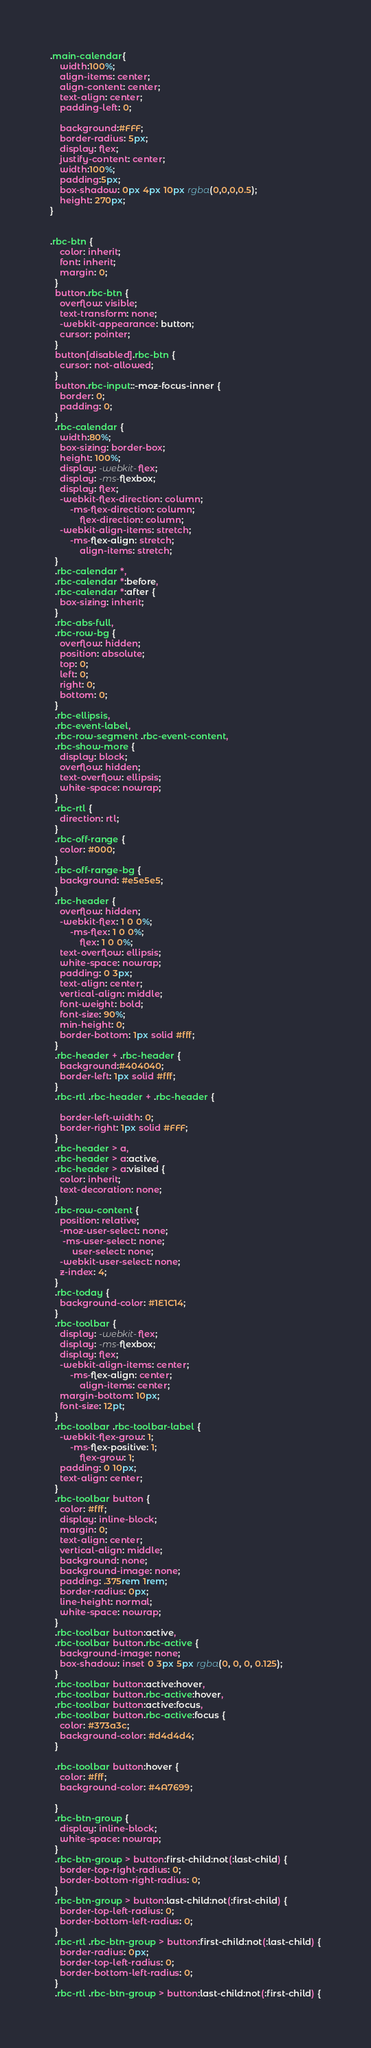Convert code to text. <code><loc_0><loc_0><loc_500><loc_500><_CSS_>.main-calendar{
    width:100%;
    align-items: center;
    align-content: center;
    text-align: center;
    padding-left: 0;
    
    background:#FFF;
    border-radius: 5px;
    display: flex;
    justify-content: center;
    width:100%;
    padding:5px;
    box-shadow: 0px 4px 10px rgba(0,0,0,0.5);
    height: 270px;
}


.rbc-btn {
    color: inherit;
    font: inherit;
    margin: 0;
  }
  button.rbc-btn {
    overflow: visible;
    text-transform: none;
    -webkit-appearance: button;
    cursor: pointer;
  }
  button[disabled].rbc-btn {
    cursor: not-allowed;
  }
  button.rbc-input::-moz-focus-inner {
    border: 0;
    padding: 0;
  }
  .rbc-calendar {
    width:80%;
    box-sizing: border-box;
    height: 100%;
    display: -webkit-flex;
    display: -ms-flexbox;
    display: flex;
    -webkit-flex-direction: column;
        -ms-flex-direction: column;
            flex-direction: column;
    -webkit-align-items: stretch;
        -ms-flex-align: stretch;
            align-items: stretch;
  }
  .rbc-calendar *,
  .rbc-calendar *:before,
  .rbc-calendar *:after {
    box-sizing: inherit;
  }
  .rbc-abs-full,
  .rbc-row-bg {
    overflow: hidden;
    position: absolute;
    top: 0;
    left: 0;
    right: 0;
    bottom: 0;
  }
  .rbc-ellipsis,
  .rbc-event-label,
  .rbc-row-segment .rbc-event-content,
  .rbc-show-more {
    display: block;
    overflow: hidden;
    text-overflow: ellipsis;
    white-space: nowrap;
  }
  .rbc-rtl {
    direction: rtl;
  }
  .rbc-off-range {
    color: #000;
  }
  .rbc-off-range-bg {
    background: #e5e5e5;
  }
  .rbc-header {
    overflow: hidden;
    -webkit-flex: 1 0 0%;
        -ms-flex: 1 0 0%;
            flex: 1 0 0%;
    text-overflow: ellipsis;
    white-space: nowrap;
    padding: 0 3px;
    text-align: center;
    vertical-align: middle;
    font-weight: bold;
    font-size: 90%;
    min-height: 0;
    border-bottom: 1px solid #fff;
  }
  .rbc-header + .rbc-header {
    background:#404040;
    border-left: 1px solid #fff;
  }
  .rbc-rtl .rbc-header + .rbc-header {
      
    border-left-width: 0;
    border-right: 1px solid #FFF;
  }
  .rbc-header > a,
  .rbc-header > a:active,
  .rbc-header > a:visited {
    color: inherit;
    text-decoration: none;
  }
  .rbc-row-content {
    position: relative;
    -moz-user-select: none;
     -ms-user-select: none;
         user-select: none;
    -webkit-user-select: none;
    z-index: 4;
  }
  .rbc-today {
    background-color: #1E1C14;
  }
  .rbc-toolbar {
    display: -webkit-flex;
    display: -ms-flexbox;
    display: flex;
    -webkit-align-items: center;
        -ms-flex-align: center;
            align-items: center;
    margin-bottom: 10px;
    font-size: 12pt;
  }
  .rbc-toolbar .rbc-toolbar-label {
    -webkit-flex-grow: 1;
        -ms-flex-positive: 1;
            flex-grow: 1;
    padding: 0 10px;
    text-align: center;
  }
  .rbc-toolbar button {
    color: #fff;
    display: inline-block;
    margin: 0;
    text-align: center;
    vertical-align: middle;
    background: none;
    background-image: none;
    padding: .375rem 1rem;
    border-radius: 0px;
    line-height: normal;
    white-space: nowrap;
  }
  .rbc-toolbar button:active,
  .rbc-toolbar button.rbc-active {
    background-image: none;
    box-shadow: inset 0 3px 5px rgba(0, 0, 0, 0.125);
  }
  .rbc-toolbar button:active:hover,
  .rbc-toolbar button.rbc-active:hover,
  .rbc-toolbar button:active:focus,
  .rbc-toolbar button.rbc-active:focus {
    color: #373a3c;
    background-color: #d4d4d4;
  }

  .rbc-toolbar button:hover {
    color: #fff;
    background-color: #4A7699;
   
  }
  .rbc-btn-group {
    display: inline-block;
    white-space: nowrap;
  }
  .rbc-btn-group > button:first-child:not(:last-child) {
    border-top-right-radius: 0;
    border-bottom-right-radius: 0;
  }
  .rbc-btn-group > button:last-child:not(:first-child) {
    border-top-left-radius: 0;
    border-bottom-left-radius: 0;
  }
  .rbc-rtl .rbc-btn-group > button:first-child:not(:last-child) {
    border-radius: 0px;
    border-top-left-radius: 0;
    border-bottom-left-radius: 0;
  }
  .rbc-rtl .rbc-btn-group > button:last-child:not(:first-child) {</code> 